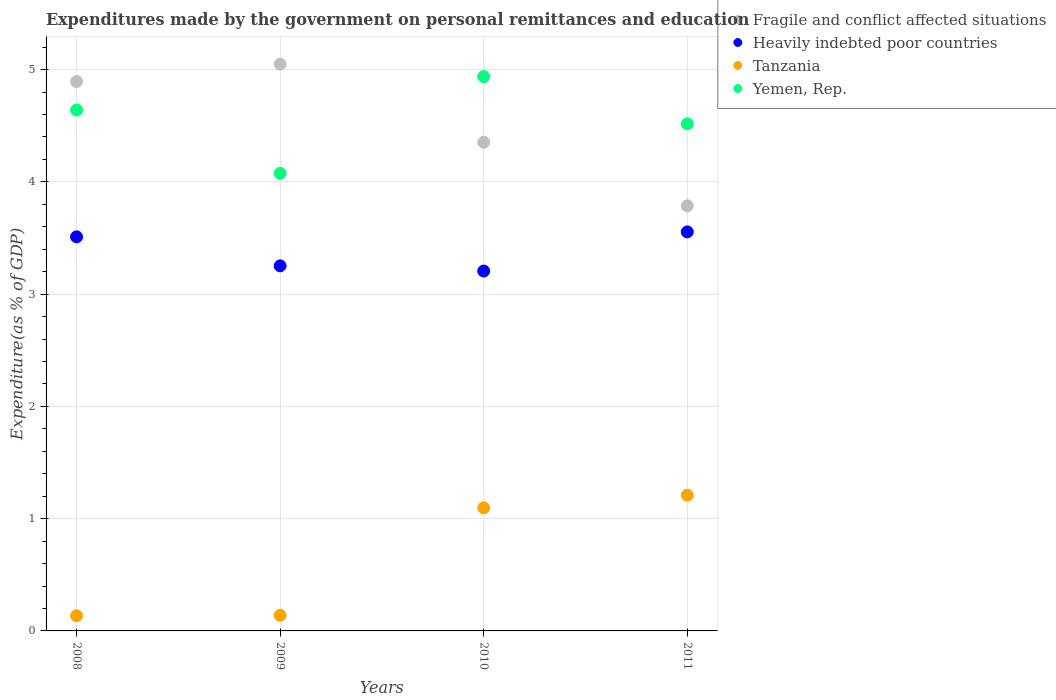What is the expenditures made by the government on personal remittances and education in Heavily indebted poor countries in 2010?
Make the answer very short. 3.21. Across all years, what is the maximum expenditures made by the government on personal remittances and education in Fragile and conflict affected situations?
Provide a short and direct response. 5.05. Across all years, what is the minimum expenditures made by the government on personal remittances and education in Yemen, Rep.?
Your response must be concise. 4.08. In which year was the expenditures made by the government on personal remittances and education in Fragile and conflict affected situations maximum?
Provide a succinct answer. 2009. What is the total expenditures made by the government on personal remittances and education in Yemen, Rep. in the graph?
Offer a very short reply. 18.17. What is the difference between the expenditures made by the government on personal remittances and education in Yemen, Rep. in 2009 and that in 2011?
Make the answer very short. -0.44. What is the difference between the expenditures made by the government on personal remittances and education in Tanzania in 2010 and the expenditures made by the government on personal remittances and education in Yemen, Rep. in 2009?
Your answer should be very brief. -2.98. What is the average expenditures made by the government on personal remittances and education in Heavily indebted poor countries per year?
Keep it short and to the point. 3.38. In the year 2009, what is the difference between the expenditures made by the government on personal remittances and education in Tanzania and expenditures made by the government on personal remittances and education in Fragile and conflict affected situations?
Give a very brief answer. -4.91. In how many years, is the expenditures made by the government on personal remittances and education in Yemen, Rep. greater than 4.2 %?
Your answer should be very brief. 3. What is the ratio of the expenditures made by the government on personal remittances and education in Tanzania in 2008 to that in 2009?
Give a very brief answer. 0.97. Is the expenditures made by the government on personal remittances and education in Heavily indebted poor countries in 2008 less than that in 2011?
Your answer should be compact. Yes. What is the difference between the highest and the second highest expenditures made by the government on personal remittances and education in Heavily indebted poor countries?
Give a very brief answer. 0.04. What is the difference between the highest and the lowest expenditures made by the government on personal remittances and education in Fragile and conflict affected situations?
Offer a terse response. 1.26. In how many years, is the expenditures made by the government on personal remittances and education in Fragile and conflict affected situations greater than the average expenditures made by the government on personal remittances and education in Fragile and conflict affected situations taken over all years?
Your answer should be very brief. 2. Is the sum of the expenditures made by the government on personal remittances and education in Tanzania in 2010 and 2011 greater than the maximum expenditures made by the government on personal remittances and education in Heavily indebted poor countries across all years?
Your response must be concise. No. Does the expenditures made by the government on personal remittances and education in Fragile and conflict affected situations monotonically increase over the years?
Ensure brevity in your answer.  No. Is the expenditures made by the government on personal remittances and education in Heavily indebted poor countries strictly greater than the expenditures made by the government on personal remittances and education in Yemen, Rep. over the years?
Your answer should be very brief. No. Is the expenditures made by the government on personal remittances and education in Fragile and conflict affected situations strictly less than the expenditures made by the government on personal remittances and education in Yemen, Rep. over the years?
Give a very brief answer. No. How many dotlines are there?
Offer a terse response. 4. How many years are there in the graph?
Keep it short and to the point. 4. What is the difference between two consecutive major ticks on the Y-axis?
Offer a very short reply. 1. Are the values on the major ticks of Y-axis written in scientific E-notation?
Provide a short and direct response. No. Does the graph contain any zero values?
Give a very brief answer. No. How many legend labels are there?
Your answer should be compact. 4. What is the title of the graph?
Offer a very short reply. Expenditures made by the government on personal remittances and education. Does "High income" appear as one of the legend labels in the graph?
Your answer should be very brief. No. What is the label or title of the X-axis?
Provide a succinct answer. Years. What is the label or title of the Y-axis?
Provide a succinct answer. Expenditure(as % of GDP). What is the Expenditure(as % of GDP) of Fragile and conflict affected situations in 2008?
Give a very brief answer. 4.89. What is the Expenditure(as % of GDP) of Heavily indebted poor countries in 2008?
Provide a short and direct response. 3.51. What is the Expenditure(as % of GDP) of Tanzania in 2008?
Make the answer very short. 0.13. What is the Expenditure(as % of GDP) in Yemen, Rep. in 2008?
Provide a short and direct response. 4.64. What is the Expenditure(as % of GDP) in Fragile and conflict affected situations in 2009?
Offer a very short reply. 5.05. What is the Expenditure(as % of GDP) in Heavily indebted poor countries in 2009?
Your answer should be very brief. 3.25. What is the Expenditure(as % of GDP) in Tanzania in 2009?
Provide a short and direct response. 0.14. What is the Expenditure(as % of GDP) in Yemen, Rep. in 2009?
Keep it short and to the point. 4.08. What is the Expenditure(as % of GDP) in Fragile and conflict affected situations in 2010?
Provide a short and direct response. 4.35. What is the Expenditure(as % of GDP) of Heavily indebted poor countries in 2010?
Offer a terse response. 3.21. What is the Expenditure(as % of GDP) of Tanzania in 2010?
Provide a succinct answer. 1.1. What is the Expenditure(as % of GDP) of Yemen, Rep. in 2010?
Your response must be concise. 4.94. What is the Expenditure(as % of GDP) in Fragile and conflict affected situations in 2011?
Ensure brevity in your answer.  3.79. What is the Expenditure(as % of GDP) in Heavily indebted poor countries in 2011?
Your answer should be very brief. 3.55. What is the Expenditure(as % of GDP) of Tanzania in 2011?
Your answer should be very brief. 1.21. What is the Expenditure(as % of GDP) of Yemen, Rep. in 2011?
Offer a terse response. 4.52. Across all years, what is the maximum Expenditure(as % of GDP) in Fragile and conflict affected situations?
Your answer should be compact. 5.05. Across all years, what is the maximum Expenditure(as % of GDP) in Heavily indebted poor countries?
Your answer should be very brief. 3.55. Across all years, what is the maximum Expenditure(as % of GDP) in Tanzania?
Offer a terse response. 1.21. Across all years, what is the maximum Expenditure(as % of GDP) in Yemen, Rep.?
Your answer should be very brief. 4.94. Across all years, what is the minimum Expenditure(as % of GDP) of Fragile and conflict affected situations?
Make the answer very short. 3.79. Across all years, what is the minimum Expenditure(as % of GDP) in Heavily indebted poor countries?
Ensure brevity in your answer.  3.21. Across all years, what is the minimum Expenditure(as % of GDP) of Tanzania?
Provide a short and direct response. 0.13. Across all years, what is the minimum Expenditure(as % of GDP) of Yemen, Rep.?
Your response must be concise. 4.08. What is the total Expenditure(as % of GDP) of Fragile and conflict affected situations in the graph?
Keep it short and to the point. 18.08. What is the total Expenditure(as % of GDP) of Heavily indebted poor countries in the graph?
Offer a very short reply. 13.52. What is the total Expenditure(as % of GDP) in Tanzania in the graph?
Your answer should be very brief. 2.58. What is the total Expenditure(as % of GDP) in Yemen, Rep. in the graph?
Offer a very short reply. 18.17. What is the difference between the Expenditure(as % of GDP) in Fragile and conflict affected situations in 2008 and that in 2009?
Keep it short and to the point. -0.15. What is the difference between the Expenditure(as % of GDP) in Heavily indebted poor countries in 2008 and that in 2009?
Offer a terse response. 0.26. What is the difference between the Expenditure(as % of GDP) in Tanzania in 2008 and that in 2009?
Provide a short and direct response. -0. What is the difference between the Expenditure(as % of GDP) in Yemen, Rep. in 2008 and that in 2009?
Provide a short and direct response. 0.56. What is the difference between the Expenditure(as % of GDP) of Fragile and conflict affected situations in 2008 and that in 2010?
Your response must be concise. 0.54. What is the difference between the Expenditure(as % of GDP) in Heavily indebted poor countries in 2008 and that in 2010?
Offer a very short reply. 0.3. What is the difference between the Expenditure(as % of GDP) in Tanzania in 2008 and that in 2010?
Offer a very short reply. -0.96. What is the difference between the Expenditure(as % of GDP) in Yemen, Rep. in 2008 and that in 2010?
Your answer should be very brief. -0.3. What is the difference between the Expenditure(as % of GDP) of Fragile and conflict affected situations in 2008 and that in 2011?
Your answer should be very brief. 1.11. What is the difference between the Expenditure(as % of GDP) in Heavily indebted poor countries in 2008 and that in 2011?
Your response must be concise. -0.04. What is the difference between the Expenditure(as % of GDP) of Tanzania in 2008 and that in 2011?
Provide a short and direct response. -1.07. What is the difference between the Expenditure(as % of GDP) of Yemen, Rep. in 2008 and that in 2011?
Offer a very short reply. 0.12. What is the difference between the Expenditure(as % of GDP) of Fragile and conflict affected situations in 2009 and that in 2010?
Your answer should be compact. 0.7. What is the difference between the Expenditure(as % of GDP) of Heavily indebted poor countries in 2009 and that in 2010?
Offer a terse response. 0.05. What is the difference between the Expenditure(as % of GDP) in Tanzania in 2009 and that in 2010?
Offer a terse response. -0.96. What is the difference between the Expenditure(as % of GDP) of Yemen, Rep. in 2009 and that in 2010?
Ensure brevity in your answer.  -0.86. What is the difference between the Expenditure(as % of GDP) in Fragile and conflict affected situations in 2009 and that in 2011?
Give a very brief answer. 1.26. What is the difference between the Expenditure(as % of GDP) in Heavily indebted poor countries in 2009 and that in 2011?
Your response must be concise. -0.3. What is the difference between the Expenditure(as % of GDP) of Tanzania in 2009 and that in 2011?
Provide a succinct answer. -1.07. What is the difference between the Expenditure(as % of GDP) of Yemen, Rep. in 2009 and that in 2011?
Provide a short and direct response. -0.44. What is the difference between the Expenditure(as % of GDP) of Fragile and conflict affected situations in 2010 and that in 2011?
Your answer should be very brief. 0.57. What is the difference between the Expenditure(as % of GDP) in Heavily indebted poor countries in 2010 and that in 2011?
Provide a succinct answer. -0.35. What is the difference between the Expenditure(as % of GDP) in Tanzania in 2010 and that in 2011?
Provide a short and direct response. -0.11. What is the difference between the Expenditure(as % of GDP) in Yemen, Rep. in 2010 and that in 2011?
Provide a short and direct response. 0.42. What is the difference between the Expenditure(as % of GDP) in Fragile and conflict affected situations in 2008 and the Expenditure(as % of GDP) in Heavily indebted poor countries in 2009?
Your answer should be very brief. 1.64. What is the difference between the Expenditure(as % of GDP) in Fragile and conflict affected situations in 2008 and the Expenditure(as % of GDP) in Tanzania in 2009?
Offer a very short reply. 4.75. What is the difference between the Expenditure(as % of GDP) in Fragile and conflict affected situations in 2008 and the Expenditure(as % of GDP) in Yemen, Rep. in 2009?
Keep it short and to the point. 0.82. What is the difference between the Expenditure(as % of GDP) in Heavily indebted poor countries in 2008 and the Expenditure(as % of GDP) in Tanzania in 2009?
Keep it short and to the point. 3.37. What is the difference between the Expenditure(as % of GDP) of Heavily indebted poor countries in 2008 and the Expenditure(as % of GDP) of Yemen, Rep. in 2009?
Offer a very short reply. -0.57. What is the difference between the Expenditure(as % of GDP) of Tanzania in 2008 and the Expenditure(as % of GDP) of Yemen, Rep. in 2009?
Give a very brief answer. -3.94. What is the difference between the Expenditure(as % of GDP) of Fragile and conflict affected situations in 2008 and the Expenditure(as % of GDP) of Heavily indebted poor countries in 2010?
Provide a succinct answer. 1.69. What is the difference between the Expenditure(as % of GDP) of Fragile and conflict affected situations in 2008 and the Expenditure(as % of GDP) of Tanzania in 2010?
Make the answer very short. 3.8. What is the difference between the Expenditure(as % of GDP) of Fragile and conflict affected situations in 2008 and the Expenditure(as % of GDP) of Yemen, Rep. in 2010?
Offer a very short reply. -0.04. What is the difference between the Expenditure(as % of GDP) of Heavily indebted poor countries in 2008 and the Expenditure(as % of GDP) of Tanzania in 2010?
Your answer should be very brief. 2.41. What is the difference between the Expenditure(as % of GDP) in Heavily indebted poor countries in 2008 and the Expenditure(as % of GDP) in Yemen, Rep. in 2010?
Your response must be concise. -1.43. What is the difference between the Expenditure(as % of GDP) of Tanzania in 2008 and the Expenditure(as % of GDP) of Yemen, Rep. in 2010?
Ensure brevity in your answer.  -4.8. What is the difference between the Expenditure(as % of GDP) of Fragile and conflict affected situations in 2008 and the Expenditure(as % of GDP) of Heavily indebted poor countries in 2011?
Make the answer very short. 1.34. What is the difference between the Expenditure(as % of GDP) in Fragile and conflict affected situations in 2008 and the Expenditure(as % of GDP) in Tanzania in 2011?
Provide a succinct answer. 3.69. What is the difference between the Expenditure(as % of GDP) of Fragile and conflict affected situations in 2008 and the Expenditure(as % of GDP) of Yemen, Rep. in 2011?
Your answer should be compact. 0.38. What is the difference between the Expenditure(as % of GDP) of Heavily indebted poor countries in 2008 and the Expenditure(as % of GDP) of Tanzania in 2011?
Keep it short and to the point. 2.3. What is the difference between the Expenditure(as % of GDP) in Heavily indebted poor countries in 2008 and the Expenditure(as % of GDP) in Yemen, Rep. in 2011?
Your response must be concise. -1.01. What is the difference between the Expenditure(as % of GDP) in Tanzania in 2008 and the Expenditure(as % of GDP) in Yemen, Rep. in 2011?
Give a very brief answer. -4.38. What is the difference between the Expenditure(as % of GDP) in Fragile and conflict affected situations in 2009 and the Expenditure(as % of GDP) in Heavily indebted poor countries in 2010?
Provide a short and direct response. 1.84. What is the difference between the Expenditure(as % of GDP) in Fragile and conflict affected situations in 2009 and the Expenditure(as % of GDP) in Tanzania in 2010?
Your answer should be compact. 3.95. What is the difference between the Expenditure(as % of GDP) in Fragile and conflict affected situations in 2009 and the Expenditure(as % of GDP) in Yemen, Rep. in 2010?
Ensure brevity in your answer.  0.11. What is the difference between the Expenditure(as % of GDP) of Heavily indebted poor countries in 2009 and the Expenditure(as % of GDP) of Tanzania in 2010?
Offer a terse response. 2.16. What is the difference between the Expenditure(as % of GDP) of Heavily indebted poor countries in 2009 and the Expenditure(as % of GDP) of Yemen, Rep. in 2010?
Make the answer very short. -1.69. What is the difference between the Expenditure(as % of GDP) of Tanzania in 2009 and the Expenditure(as % of GDP) of Yemen, Rep. in 2010?
Ensure brevity in your answer.  -4.8. What is the difference between the Expenditure(as % of GDP) in Fragile and conflict affected situations in 2009 and the Expenditure(as % of GDP) in Heavily indebted poor countries in 2011?
Keep it short and to the point. 1.49. What is the difference between the Expenditure(as % of GDP) of Fragile and conflict affected situations in 2009 and the Expenditure(as % of GDP) of Tanzania in 2011?
Make the answer very short. 3.84. What is the difference between the Expenditure(as % of GDP) in Fragile and conflict affected situations in 2009 and the Expenditure(as % of GDP) in Yemen, Rep. in 2011?
Provide a succinct answer. 0.53. What is the difference between the Expenditure(as % of GDP) in Heavily indebted poor countries in 2009 and the Expenditure(as % of GDP) in Tanzania in 2011?
Offer a terse response. 2.04. What is the difference between the Expenditure(as % of GDP) of Heavily indebted poor countries in 2009 and the Expenditure(as % of GDP) of Yemen, Rep. in 2011?
Ensure brevity in your answer.  -1.27. What is the difference between the Expenditure(as % of GDP) of Tanzania in 2009 and the Expenditure(as % of GDP) of Yemen, Rep. in 2011?
Keep it short and to the point. -4.38. What is the difference between the Expenditure(as % of GDP) in Fragile and conflict affected situations in 2010 and the Expenditure(as % of GDP) in Heavily indebted poor countries in 2011?
Your answer should be compact. 0.8. What is the difference between the Expenditure(as % of GDP) in Fragile and conflict affected situations in 2010 and the Expenditure(as % of GDP) in Tanzania in 2011?
Provide a succinct answer. 3.14. What is the difference between the Expenditure(as % of GDP) in Fragile and conflict affected situations in 2010 and the Expenditure(as % of GDP) in Yemen, Rep. in 2011?
Offer a very short reply. -0.17. What is the difference between the Expenditure(as % of GDP) in Heavily indebted poor countries in 2010 and the Expenditure(as % of GDP) in Tanzania in 2011?
Make the answer very short. 2. What is the difference between the Expenditure(as % of GDP) of Heavily indebted poor countries in 2010 and the Expenditure(as % of GDP) of Yemen, Rep. in 2011?
Your answer should be very brief. -1.31. What is the difference between the Expenditure(as % of GDP) of Tanzania in 2010 and the Expenditure(as % of GDP) of Yemen, Rep. in 2011?
Make the answer very short. -3.42. What is the average Expenditure(as % of GDP) of Fragile and conflict affected situations per year?
Your response must be concise. 4.52. What is the average Expenditure(as % of GDP) of Heavily indebted poor countries per year?
Your answer should be very brief. 3.38. What is the average Expenditure(as % of GDP) of Tanzania per year?
Ensure brevity in your answer.  0.64. What is the average Expenditure(as % of GDP) in Yemen, Rep. per year?
Your response must be concise. 4.54. In the year 2008, what is the difference between the Expenditure(as % of GDP) of Fragile and conflict affected situations and Expenditure(as % of GDP) of Heavily indebted poor countries?
Offer a terse response. 1.38. In the year 2008, what is the difference between the Expenditure(as % of GDP) of Fragile and conflict affected situations and Expenditure(as % of GDP) of Tanzania?
Make the answer very short. 4.76. In the year 2008, what is the difference between the Expenditure(as % of GDP) in Fragile and conflict affected situations and Expenditure(as % of GDP) in Yemen, Rep.?
Provide a short and direct response. 0.25. In the year 2008, what is the difference between the Expenditure(as % of GDP) of Heavily indebted poor countries and Expenditure(as % of GDP) of Tanzania?
Offer a terse response. 3.38. In the year 2008, what is the difference between the Expenditure(as % of GDP) in Heavily indebted poor countries and Expenditure(as % of GDP) in Yemen, Rep.?
Give a very brief answer. -1.13. In the year 2008, what is the difference between the Expenditure(as % of GDP) in Tanzania and Expenditure(as % of GDP) in Yemen, Rep.?
Ensure brevity in your answer.  -4.51. In the year 2009, what is the difference between the Expenditure(as % of GDP) of Fragile and conflict affected situations and Expenditure(as % of GDP) of Heavily indebted poor countries?
Provide a succinct answer. 1.8. In the year 2009, what is the difference between the Expenditure(as % of GDP) in Fragile and conflict affected situations and Expenditure(as % of GDP) in Tanzania?
Your response must be concise. 4.91. In the year 2009, what is the difference between the Expenditure(as % of GDP) of Fragile and conflict affected situations and Expenditure(as % of GDP) of Yemen, Rep.?
Make the answer very short. 0.97. In the year 2009, what is the difference between the Expenditure(as % of GDP) of Heavily indebted poor countries and Expenditure(as % of GDP) of Tanzania?
Your answer should be compact. 3.11. In the year 2009, what is the difference between the Expenditure(as % of GDP) in Heavily indebted poor countries and Expenditure(as % of GDP) in Yemen, Rep.?
Offer a very short reply. -0.82. In the year 2009, what is the difference between the Expenditure(as % of GDP) of Tanzania and Expenditure(as % of GDP) of Yemen, Rep.?
Your answer should be compact. -3.94. In the year 2010, what is the difference between the Expenditure(as % of GDP) in Fragile and conflict affected situations and Expenditure(as % of GDP) in Heavily indebted poor countries?
Your response must be concise. 1.15. In the year 2010, what is the difference between the Expenditure(as % of GDP) of Fragile and conflict affected situations and Expenditure(as % of GDP) of Tanzania?
Your answer should be very brief. 3.26. In the year 2010, what is the difference between the Expenditure(as % of GDP) of Fragile and conflict affected situations and Expenditure(as % of GDP) of Yemen, Rep.?
Make the answer very short. -0.59. In the year 2010, what is the difference between the Expenditure(as % of GDP) in Heavily indebted poor countries and Expenditure(as % of GDP) in Tanzania?
Your answer should be compact. 2.11. In the year 2010, what is the difference between the Expenditure(as % of GDP) of Heavily indebted poor countries and Expenditure(as % of GDP) of Yemen, Rep.?
Ensure brevity in your answer.  -1.73. In the year 2010, what is the difference between the Expenditure(as % of GDP) of Tanzania and Expenditure(as % of GDP) of Yemen, Rep.?
Offer a terse response. -3.84. In the year 2011, what is the difference between the Expenditure(as % of GDP) in Fragile and conflict affected situations and Expenditure(as % of GDP) in Heavily indebted poor countries?
Keep it short and to the point. 0.23. In the year 2011, what is the difference between the Expenditure(as % of GDP) of Fragile and conflict affected situations and Expenditure(as % of GDP) of Tanzania?
Offer a terse response. 2.58. In the year 2011, what is the difference between the Expenditure(as % of GDP) in Fragile and conflict affected situations and Expenditure(as % of GDP) in Yemen, Rep.?
Offer a terse response. -0.73. In the year 2011, what is the difference between the Expenditure(as % of GDP) in Heavily indebted poor countries and Expenditure(as % of GDP) in Tanzania?
Give a very brief answer. 2.35. In the year 2011, what is the difference between the Expenditure(as % of GDP) of Heavily indebted poor countries and Expenditure(as % of GDP) of Yemen, Rep.?
Offer a terse response. -0.96. In the year 2011, what is the difference between the Expenditure(as % of GDP) in Tanzania and Expenditure(as % of GDP) in Yemen, Rep.?
Your answer should be very brief. -3.31. What is the ratio of the Expenditure(as % of GDP) of Fragile and conflict affected situations in 2008 to that in 2009?
Your answer should be very brief. 0.97. What is the ratio of the Expenditure(as % of GDP) of Heavily indebted poor countries in 2008 to that in 2009?
Keep it short and to the point. 1.08. What is the ratio of the Expenditure(as % of GDP) in Tanzania in 2008 to that in 2009?
Your answer should be compact. 0.97. What is the ratio of the Expenditure(as % of GDP) of Yemen, Rep. in 2008 to that in 2009?
Offer a very short reply. 1.14. What is the ratio of the Expenditure(as % of GDP) in Fragile and conflict affected situations in 2008 to that in 2010?
Make the answer very short. 1.12. What is the ratio of the Expenditure(as % of GDP) of Heavily indebted poor countries in 2008 to that in 2010?
Keep it short and to the point. 1.1. What is the ratio of the Expenditure(as % of GDP) in Tanzania in 2008 to that in 2010?
Your answer should be very brief. 0.12. What is the ratio of the Expenditure(as % of GDP) in Yemen, Rep. in 2008 to that in 2010?
Offer a very short reply. 0.94. What is the ratio of the Expenditure(as % of GDP) of Fragile and conflict affected situations in 2008 to that in 2011?
Keep it short and to the point. 1.29. What is the ratio of the Expenditure(as % of GDP) of Heavily indebted poor countries in 2008 to that in 2011?
Your answer should be very brief. 0.99. What is the ratio of the Expenditure(as % of GDP) in Tanzania in 2008 to that in 2011?
Make the answer very short. 0.11. What is the ratio of the Expenditure(as % of GDP) in Yemen, Rep. in 2008 to that in 2011?
Make the answer very short. 1.03. What is the ratio of the Expenditure(as % of GDP) of Fragile and conflict affected situations in 2009 to that in 2010?
Ensure brevity in your answer.  1.16. What is the ratio of the Expenditure(as % of GDP) of Heavily indebted poor countries in 2009 to that in 2010?
Give a very brief answer. 1.01. What is the ratio of the Expenditure(as % of GDP) of Tanzania in 2009 to that in 2010?
Offer a terse response. 0.13. What is the ratio of the Expenditure(as % of GDP) of Yemen, Rep. in 2009 to that in 2010?
Offer a terse response. 0.83. What is the ratio of the Expenditure(as % of GDP) in Fragile and conflict affected situations in 2009 to that in 2011?
Your answer should be compact. 1.33. What is the ratio of the Expenditure(as % of GDP) in Heavily indebted poor countries in 2009 to that in 2011?
Provide a succinct answer. 0.91. What is the ratio of the Expenditure(as % of GDP) of Tanzania in 2009 to that in 2011?
Offer a very short reply. 0.12. What is the ratio of the Expenditure(as % of GDP) in Yemen, Rep. in 2009 to that in 2011?
Give a very brief answer. 0.9. What is the ratio of the Expenditure(as % of GDP) in Fragile and conflict affected situations in 2010 to that in 2011?
Keep it short and to the point. 1.15. What is the ratio of the Expenditure(as % of GDP) in Heavily indebted poor countries in 2010 to that in 2011?
Provide a succinct answer. 0.9. What is the ratio of the Expenditure(as % of GDP) of Tanzania in 2010 to that in 2011?
Your response must be concise. 0.91. What is the ratio of the Expenditure(as % of GDP) in Yemen, Rep. in 2010 to that in 2011?
Provide a short and direct response. 1.09. What is the difference between the highest and the second highest Expenditure(as % of GDP) in Fragile and conflict affected situations?
Keep it short and to the point. 0.15. What is the difference between the highest and the second highest Expenditure(as % of GDP) of Heavily indebted poor countries?
Offer a very short reply. 0.04. What is the difference between the highest and the second highest Expenditure(as % of GDP) of Tanzania?
Ensure brevity in your answer.  0.11. What is the difference between the highest and the second highest Expenditure(as % of GDP) in Yemen, Rep.?
Provide a succinct answer. 0.3. What is the difference between the highest and the lowest Expenditure(as % of GDP) of Fragile and conflict affected situations?
Your answer should be very brief. 1.26. What is the difference between the highest and the lowest Expenditure(as % of GDP) of Heavily indebted poor countries?
Keep it short and to the point. 0.35. What is the difference between the highest and the lowest Expenditure(as % of GDP) in Tanzania?
Offer a very short reply. 1.07. What is the difference between the highest and the lowest Expenditure(as % of GDP) in Yemen, Rep.?
Keep it short and to the point. 0.86. 